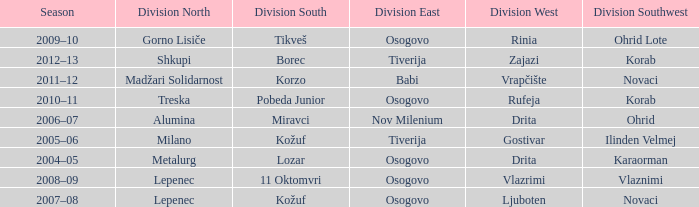Who won Division Southwest when the winner of Division North was Lepenec and Division South was won by 11 Oktomvri? Vlaznimi. 